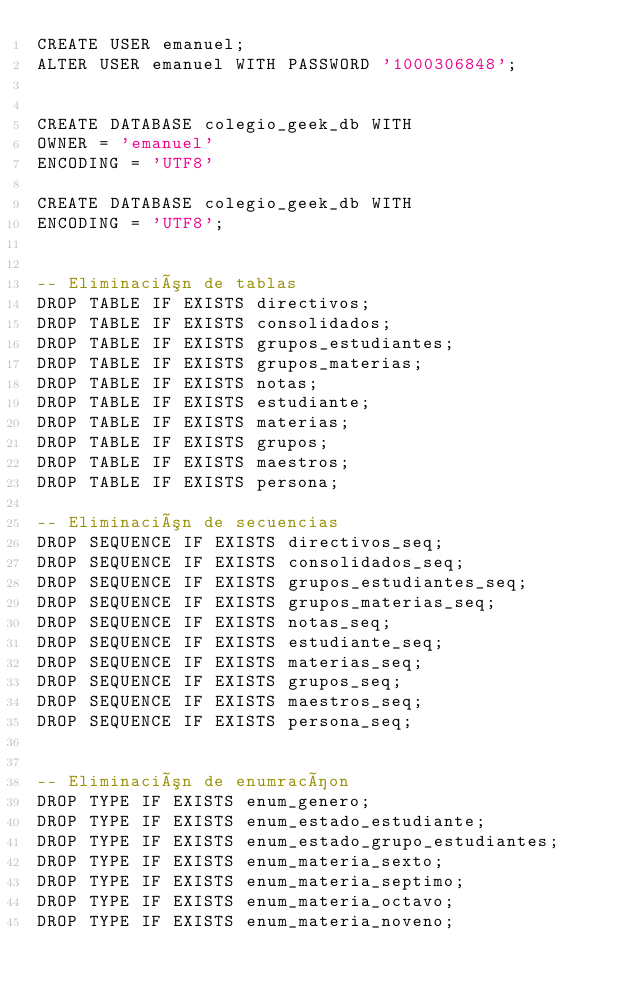<code> <loc_0><loc_0><loc_500><loc_500><_SQL_>CREATE USER emanuel;
ALTER USER emanuel WITH PASSWORD '1000306848';


CREATE DATABASE colegio_geek_db WITH 
OWNER = 'emanuel'
ENCODING = 'UTF8'

CREATE DATABASE colegio_geek_db WITH 
ENCODING = 'UTF8';


-- Eliminación de tablas
DROP TABLE IF EXISTS directivos;
DROP TABLE IF EXISTS consolidados;
DROP TABLE IF EXISTS grupos_estudiantes;
DROP TABLE IF EXISTS grupos_materias;
DROP TABLE IF EXISTS notas;
DROP TABLE IF EXISTS estudiante;
DROP TABLE IF EXISTS materias;
DROP TABLE IF EXISTS grupos;
DROP TABLE IF EXISTS maestros;
DROP TABLE IF EXISTS persona;

-- Eliminación de secuencias
DROP SEQUENCE IF EXISTS directivos_seq;
DROP SEQUENCE IF EXISTS consolidados_seq;
DROP SEQUENCE IF EXISTS grupos_estudiantes_seq;
DROP SEQUENCE IF EXISTS grupos_materias_seq;
DROP SEQUENCE IF EXISTS notas_seq;
DROP SEQUENCE IF EXISTS estudiante_seq;
DROP SEQUENCE IF EXISTS materias_seq;
DROP SEQUENCE IF EXISTS grupos_seq;
DROP SEQUENCE IF EXISTS maestros_seq;
DROP SEQUENCE IF EXISTS persona_seq;


-- Eliminación de enumracíon
DROP TYPE IF EXISTS enum_genero;
DROP TYPE IF EXISTS enum_estado_estudiante;
DROP TYPE IF EXISTS enum_estado_grupo_estudiantes;
DROP TYPE IF EXISTS enum_materia_sexto;
DROP TYPE IF EXISTS enum_materia_septimo;
DROP TYPE IF EXISTS enum_materia_octavo;
DROP TYPE IF EXISTS enum_materia_noveno;</code> 